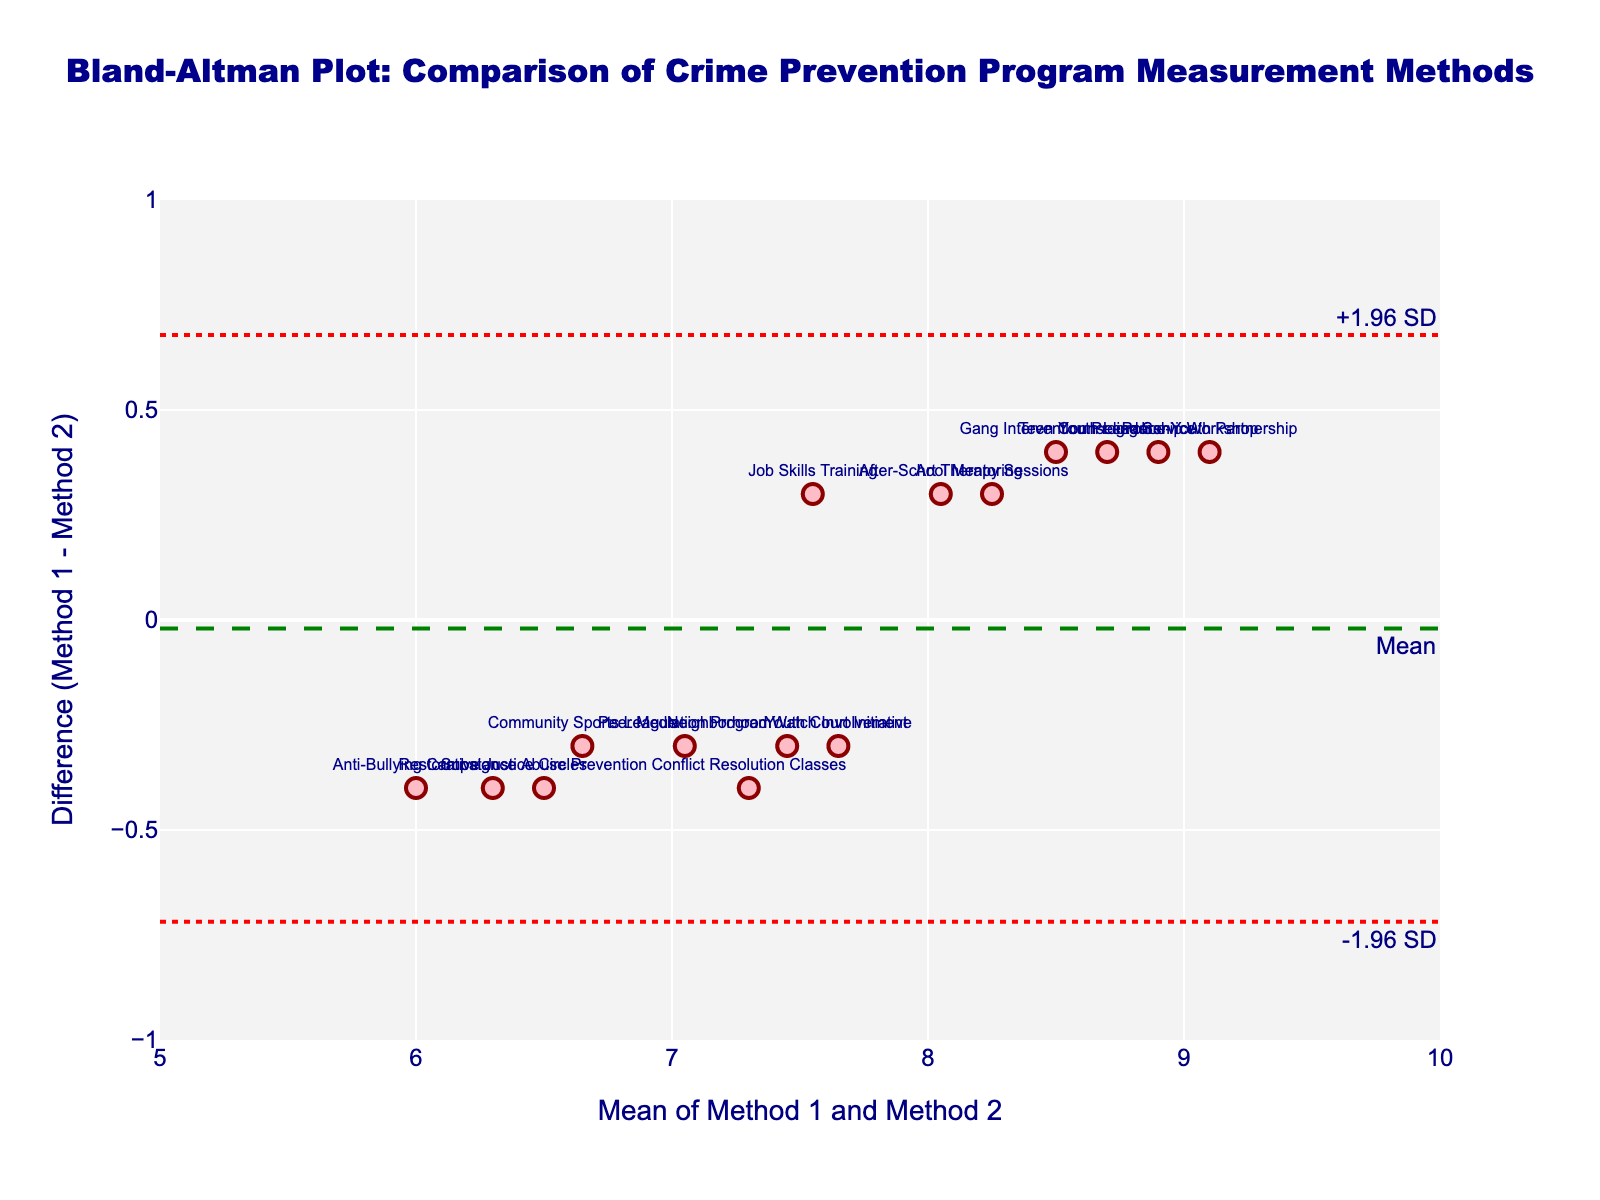What's the title of the figure? The title is displayed at the top of the figure in a prominent large font. It provides an overview of what the figure is about. The title reads, "Bland-Altman Plot: Comparison of Crime Prevention Program Measurement Methods."
Answer: Bland-Altman Plot: Comparison of Crime Prevention Program Measurement Methods How many data points are displayed in the plot? Each data point is represented by a marker on the plot. By counting the markers, we can determine the number of data points.
Answer: 15 What are the units on the x-axis? The x-axis label indicates what is being measured. In this figure, it is labeled "Mean of Method 1 and Method 2," with units marked by the tick values ranging from 5 to 10.
Answer: Mean of Method 1 and Method 2 What does the horizontal green dashed line represent? The green dashed line is labeled "Mean" and is placed horizontally across the plot, suggesting it represents the mean difference between Method 1 and Method 2 measurements.
Answer: Mean difference What do the red dotted lines signify? There are two red dotted lines, labeled "+1.96 SD" and "-1.96 SD." They represent the upper and lower limits of agreement, which are calculated as the mean difference plus or minus 1.96 times the standard deviation of the differences.
Answer: Limits of agreement Which program has the largest positive difference between Method 1 and Method 2? By locating the data point that is furthest above the x-axis, we can determine the program with the largest positive difference. The program label closest to this point is "After-School Mentoring."
Answer: After-School Mentoring Which program has the smallest negative difference between Method 1 and Method 2? By identifying the data point that is furthest below the x-axis, we can determine the program with the smallest negative difference. The program label closest to this point is "Peer Mediation Program."
Answer: Peer Mediation Program What is the approximate value of the mean difference line? Observing the point where the green dashed line intersects the y-axis gives us the mean difference. It appears to be slightly below 0 on the y-axis.
Answer: Just below 0 Are there any data points outside the limits of agreement? By checking if any markers are located beyond the red dotted lines (+1.96 SD and -1.96 SD), we determine if there are any outliers. All points are within these bounds.
Answer: No How spread out are the differences between Method 1 and Method 2 measurements? The spread can be assessed by the standard deviation of the differences, which is represented by the distance between the red dotted lines (+1.96 SD and -1.96 SD). A large distance indicates higher variability, and in this plot, the distance appears moderate to small since all data points are within 1 unit.
Answer: Moderate to small 